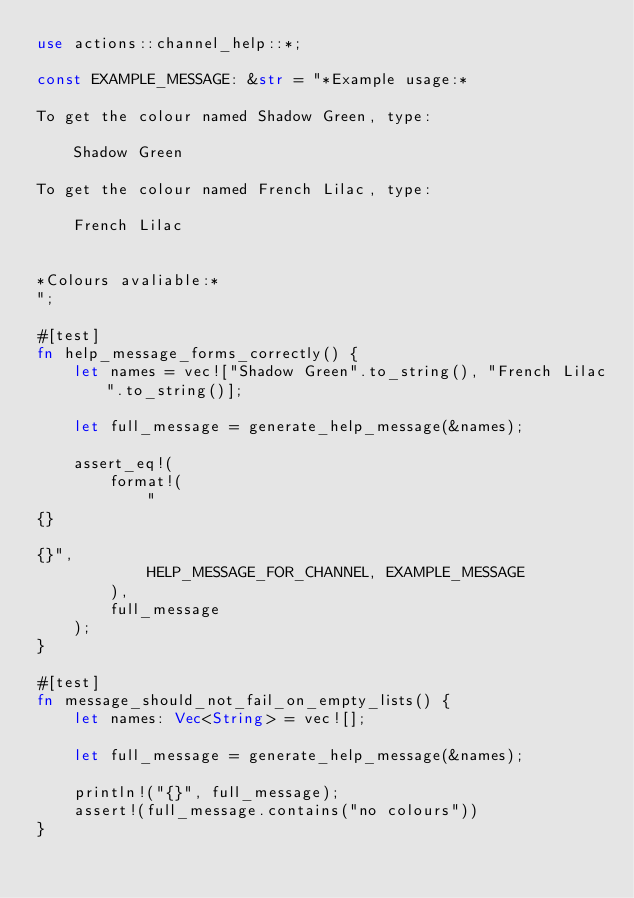Convert code to text. <code><loc_0><loc_0><loc_500><loc_500><_Rust_>use actions::channel_help::*;

const EXAMPLE_MESSAGE: &str = "*Example usage:*

To get the colour named Shadow Green, type:

    Shadow Green

To get the colour named French Lilac, type:

    French Lilac


*Colours avaliable:*
";

#[test]
fn help_message_forms_correctly() {
    let names = vec!["Shadow Green".to_string(), "French Lilac".to_string()];

    let full_message = generate_help_message(&names);

    assert_eq!(
        format!(
            "
{}

{}",
            HELP_MESSAGE_FOR_CHANNEL, EXAMPLE_MESSAGE
        ),
        full_message
    );
}

#[test]
fn message_should_not_fail_on_empty_lists() {
    let names: Vec<String> = vec![];

    let full_message = generate_help_message(&names);

    println!("{}", full_message);
    assert!(full_message.contains("no colours"))
}
</code> 